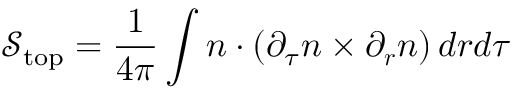Convert formula to latex. <formula><loc_0><loc_0><loc_500><loc_500>\mathcal { S } _ { t o p } = \frac { 1 } { 4 \pi } \int { n } \cdot \left ( \partial _ { \tau } n \times \partial _ { r } n \right ) d r d \tau</formula> 